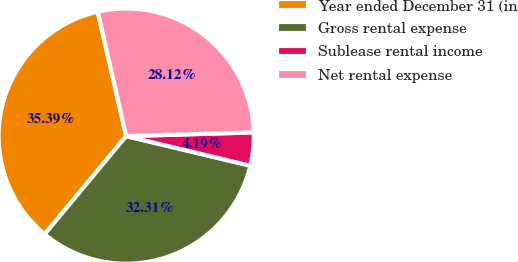<chart> <loc_0><loc_0><loc_500><loc_500><pie_chart><fcel>Year ended December 31 (in<fcel>Gross rental expense<fcel>Sublease rental income<fcel>Net rental expense<nl><fcel>35.39%<fcel>32.31%<fcel>4.19%<fcel>28.12%<nl></chart> 